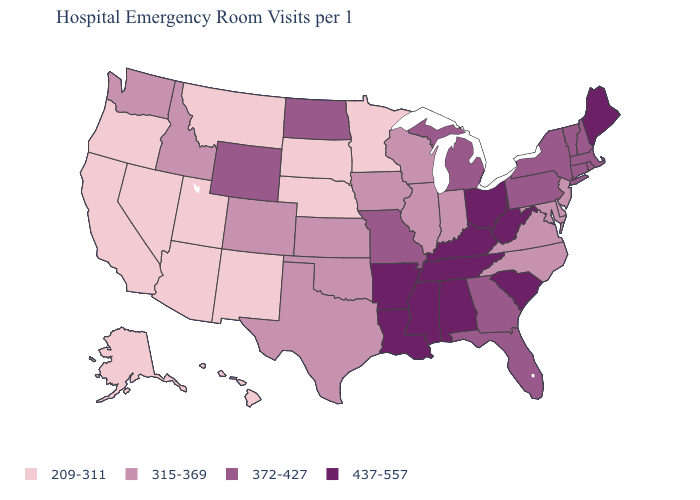Which states have the lowest value in the South?
Write a very short answer. Delaware, Maryland, North Carolina, Oklahoma, Texas, Virginia. Name the states that have a value in the range 437-557?
Answer briefly. Alabama, Arkansas, Kentucky, Louisiana, Maine, Mississippi, Ohio, South Carolina, Tennessee, West Virginia. What is the highest value in the USA?
Answer briefly. 437-557. What is the highest value in the USA?
Short answer required. 437-557. What is the value of Illinois?
Write a very short answer. 315-369. Does the first symbol in the legend represent the smallest category?
Quick response, please. Yes. Among the states that border West Virginia , does Kentucky have the lowest value?
Keep it brief. No. Among the states that border Wisconsin , which have the lowest value?
Answer briefly. Minnesota. Does Wyoming have the highest value in the West?
Quick response, please. Yes. Which states have the lowest value in the West?
Answer briefly. Alaska, Arizona, California, Hawaii, Montana, Nevada, New Mexico, Oregon, Utah. Does New Jersey have a higher value than Rhode Island?
Give a very brief answer. No. What is the value of Georgia?
Write a very short answer. 372-427. What is the lowest value in the South?
Quick response, please. 315-369. Which states have the highest value in the USA?
Be succinct. Alabama, Arkansas, Kentucky, Louisiana, Maine, Mississippi, Ohio, South Carolina, Tennessee, West Virginia. Does Vermont have the same value as Pennsylvania?
Short answer required. Yes. 